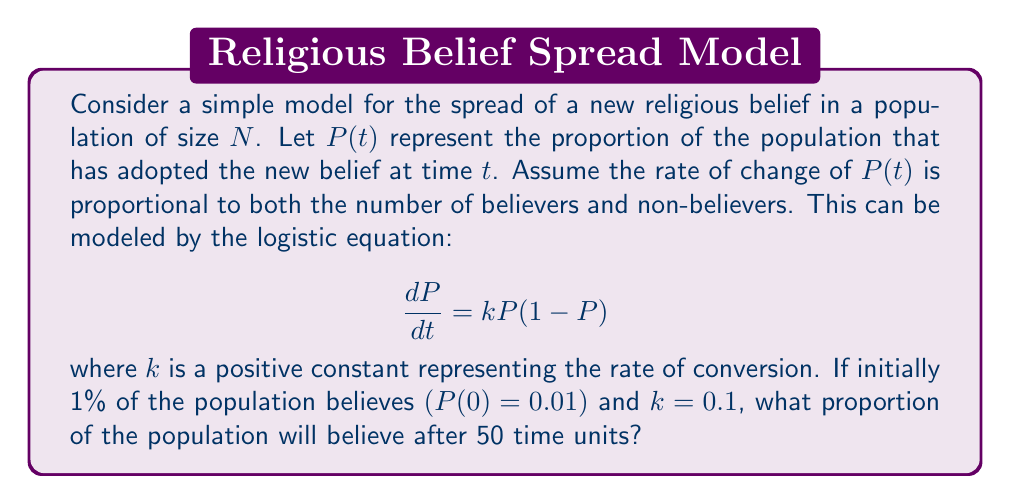Teach me how to tackle this problem. To solve this problem, we need to follow these steps:

1) The given differential equation is the logistic equation:

   $$\frac{dP}{dt} = kP(1-P)$$

2) The solution to this equation is:

   $$P(t) = \frac{P_0e^{kt}}{1-P_0+P_0e^{kt}}$$

   where $P_0$ is the initial proportion of believers.

3) We are given:
   - $P_0 = 0.01$ (initial 1% of population)
   - $k = 0.1$ (rate of conversion)
   - $t = 50$ (time units)

4) Substituting these values into the solution:

   $$P(50) = \frac{0.01e^{0.1(50)}}{1-0.01+0.01e^{0.1(50)}}$$

5) Simplify:
   $$P(50) = \frac{0.01e^5}{0.99+0.01e^5}$$

6) Calculate $e^5 \approx 148.4$:
   $$P(50) = \frac{0.01(148.4)}{0.99+0.01(148.4)} = \frac{1.484}{2.474} \approx 0.5998$$

7) Convert to a percentage: 0.5998 * 100% ≈ 59.98%

Therefore, after 50 time units, approximately 59.98% of the population will have adopted the new belief.
Answer: 59.98% 